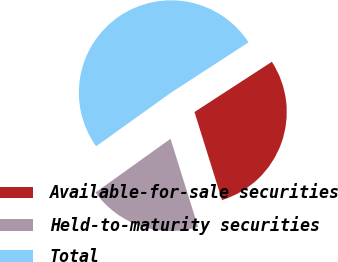Convert chart to OTSL. <chart><loc_0><loc_0><loc_500><loc_500><pie_chart><fcel>Available-for-sale securities<fcel>Held-to-maturity securities<fcel>Total<nl><fcel>29.34%<fcel>19.93%<fcel>50.72%<nl></chart> 